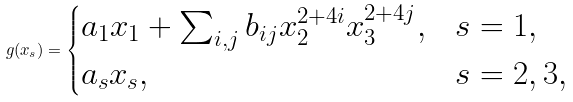<formula> <loc_0><loc_0><loc_500><loc_500>g ( x _ { s } ) = \begin{cases} a _ { 1 } x _ { 1 } + \sum _ { i , j } b _ { i j } x _ { 2 } ^ { 2 + 4 i } x _ { 3 } ^ { 2 + 4 j } , & s = 1 , \\ a _ { s } x _ { s } , & s = 2 , 3 , \end{cases}</formula> 